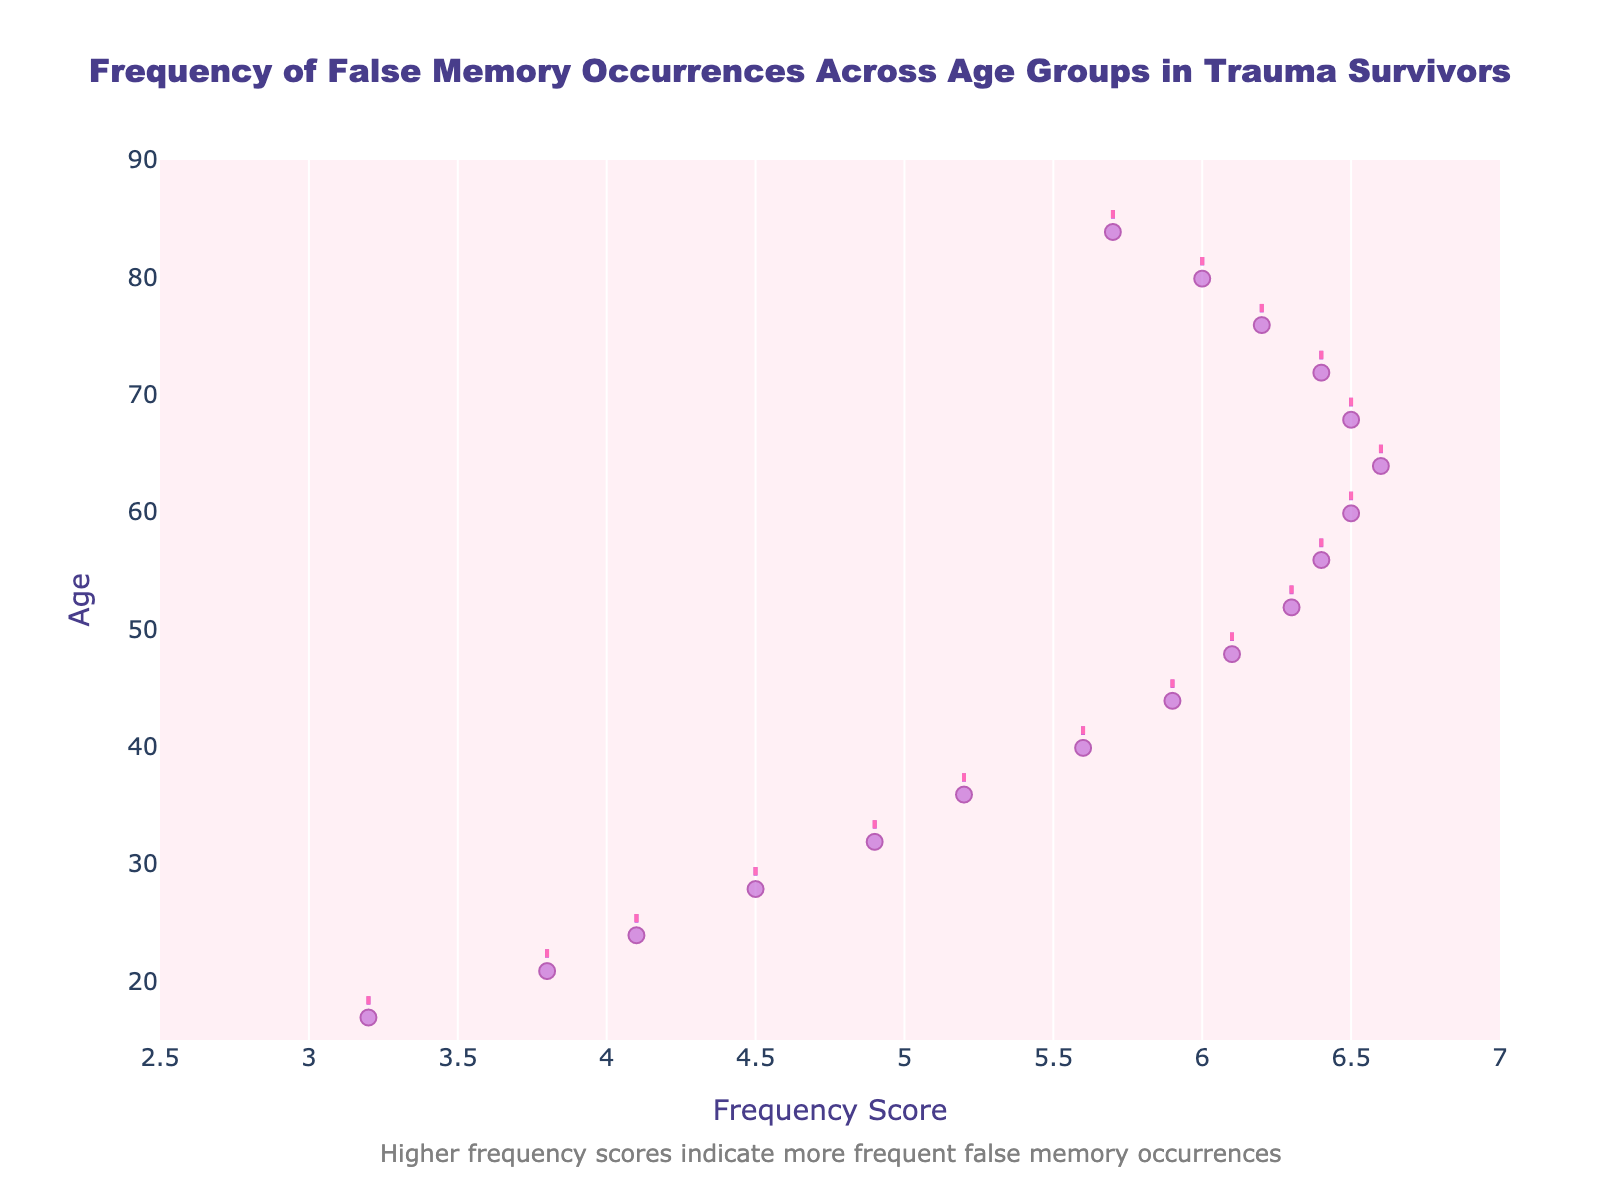What is the title of the plot? The plot's title is located at the top of the figure in bold letters. It reads "Frequency of False Memory Occurrences Across Age Groups in Trauma Survivors".
Answer: Frequency of False Memory Occurrences Across Age Groups in Trauma Survivors What are the x-axis and y-axis labels? The x-axis label is "Frequency Score" and the y-axis label is "Age". These labels are found along the respective axes in the plot.
Answer: Frequency Score, Age What color represents the density trace on the plot? The density trace in the plot is represented in a lavender shade with darker violet edges, and some annotations specify its fill color and line color.
Answer: Lavender with dark violet edges Which age group shows the highest frequency score of false memory occurrences? By looking at the density plot, the peak frequency score is around 6.6, which corresponds to the age group of 65.
Answer: Age group of 65 How does the frequency score change as age increases? Observing the trend of the density trace from 18 to 85, it generally increases until it peaks around 65 and then starts to decline.
Answer: Increases until 65, then decreases What is the average frequency score for all the age groups? To find the average, sum all the frequency scores provided, then divide by the number of age groups (18). Sum: 3.2 + 3.8 + 4.1 + 4.5 + 4.9 + 5.2 + 5.6 + 5.9 + 6.1 + 6.3 + 6.4 + 6.5 + 6.6 + 6.5 + 6.4 + 6.2 + 6.0 + 5.7 = 96.4. 96.4 / 18 ≈ 5.36
Answer: 5.36 Compare the frequency scores for age groups 22 and 73. The frequency score for age 22 is 3.8, and for age 73, it is 6.4. 6.4 - 3.8 = 2.6
Answer: Age 73 is higher by 2.6 Are there any age groups where the frequency score is constant? By looking at the plot and data points, the frequency scores do not remain constant across any two consecutive age groups, showing variability at each point.
Answer: No What is the range of frequency scores observed in the plot? The minimum frequency score is 3.2 at age 18, and the maximum is 6.6 at age 65. So, the range is 6.6 - 3.2 = 3.4
Answer: 3.4 Do older age groups (70+) show a trend in frequency scores? Observing the density plot for ages 70 and above, the frequency scores generally show a slight decreasing trend from 6.5 at age 69 to 5.7 at age 85.
Answer: Slightly decreasing trend 